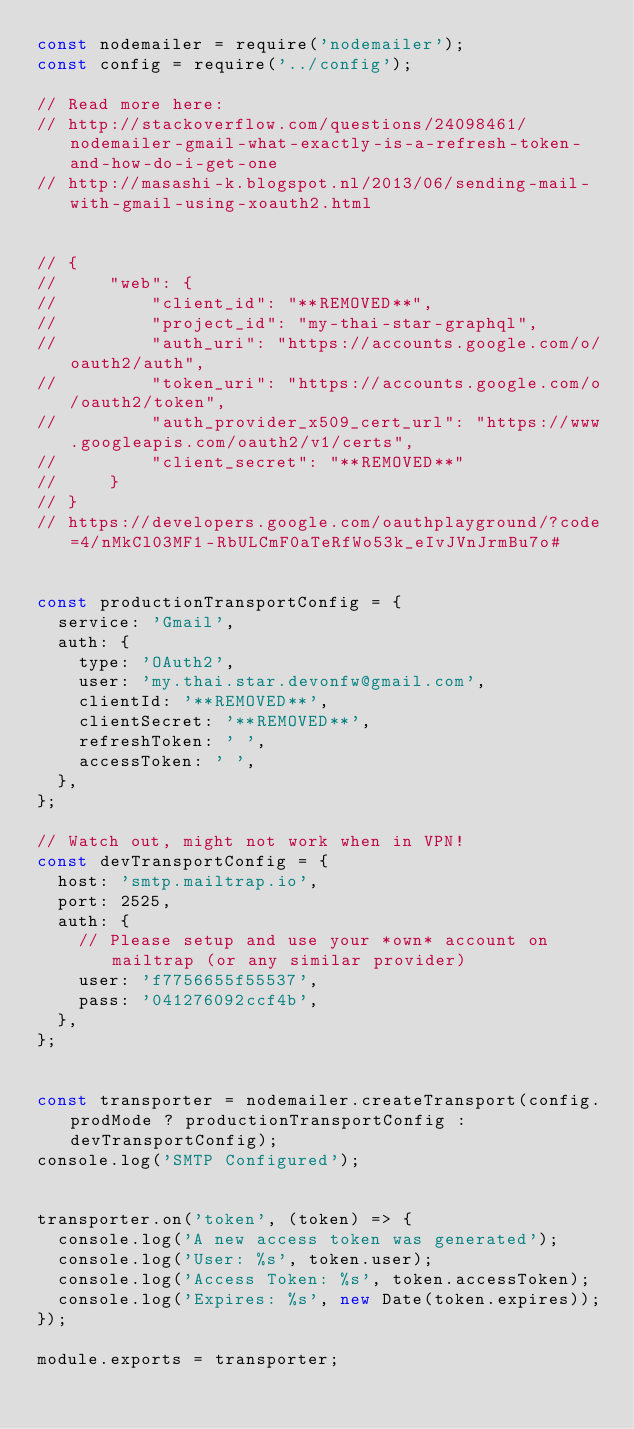<code> <loc_0><loc_0><loc_500><loc_500><_JavaScript_>const nodemailer = require('nodemailer');
const config = require('../config');

// Read more here:
// http://stackoverflow.com/questions/24098461/nodemailer-gmail-what-exactly-is-a-refresh-token-and-how-do-i-get-one
// http://masashi-k.blogspot.nl/2013/06/sending-mail-with-gmail-using-xoauth2.html


// {
//     "web": {
//         "client_id": "**REMOVED**",
//         "project_id": "my-thai-star-graphql",
//         "auth_uri": "https://accounts.google.com/o/oauth2/auth",
//         "token_uri": "https://accounts.google.com/o/oauth2/token",
//         "auth_provider_x509_cert_url": "https://www.googleapis.com/oauth2/v1/certs",
//         "client_secret": "**REMOVED**"
//     }
// }
// https://developers.google.com/oauthplayground/?code=4/nMkCl03MF1-RbULCmF0aTeRfWo53k_eIvJVnJrmBu7o#


const productionTransportConfig = {
  service: 'Gmail',
  auth: {
    type: 'OAuth2',
    user: 'my.thai.star.devonfw@gmail.com',
    clientId: '**REMOVED**',
    clientSecret: '**REMOVED**',
    refreshToken: ' ',
    accessToken: ' ',
  },
};

// Watch out, might not work when in VPN!
const devTransportConfig = {
  host: 'smtp.mailtrap.io',
  port: 2525,
  auth: {
    // Please setup and use your *own* account on mailtrap (or any similar provider)
    user: 'f7756655f55537',
    pass: '041276092ccf4b',
  },
};


const transporter = nodemailer.createTransport(config.prodMode ? productionTransportConfig : devTransportConfig);
console.log('SMTP Configured');


transporter.on('token', (token) => {
  console.log('A new access token was generated');
  console.log('User: %s', token.user);
  console.log('Access Token: %s', token.accessToken);
  console.log('Expires: %s', new Date(token.expires));
});

module.exports = transporter;
</code> 